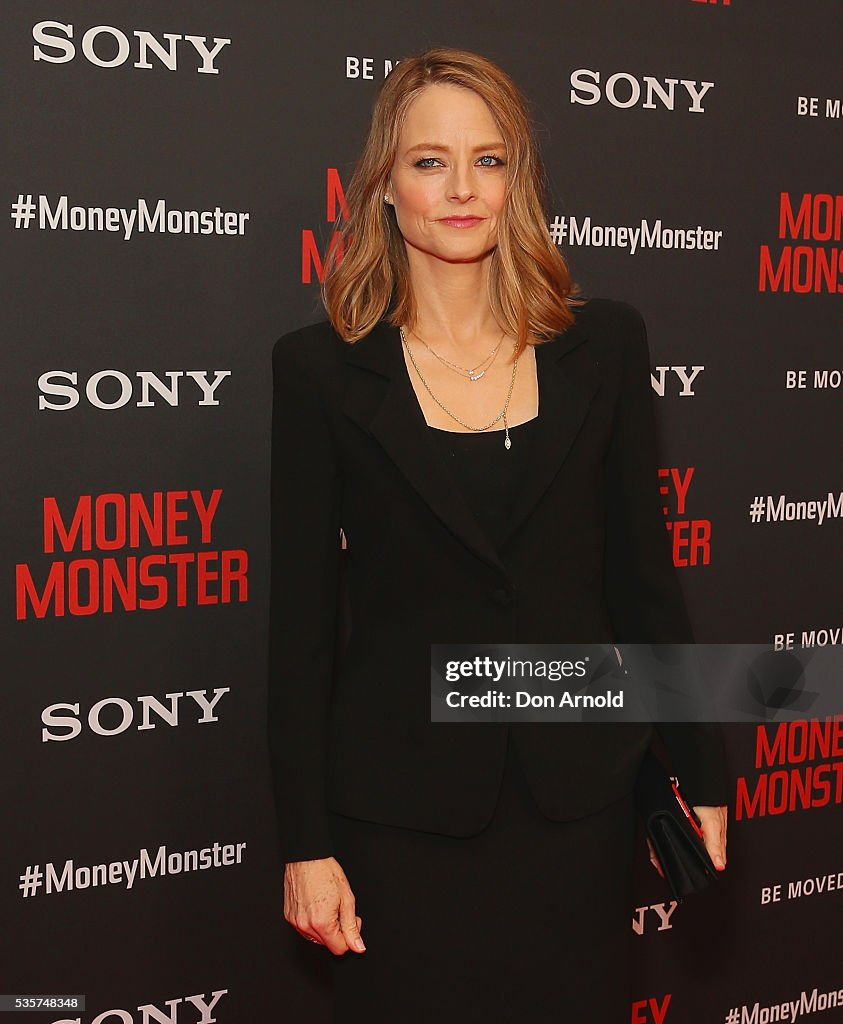Considering the fashion choices of the individual, what might be inferred about the formality of the event and the fashion trends at the time the photo was taken? The individual's attire, featuring a tailored black blazer over a black top, strongly indicates that she is attending a formal or semi-formal event. The simplicity and elegance of her outfit, complemented by understated jewelry, communicate a preference for classic and sophisticated fashion, which is often suitable for formal occasions. The black clutch she holds further aligns with her formal look and is commonly associated with such events. The fashion style, characterized by clean lines and minimal embellishments, aligns with contemporary trends favoring minimalism and timeless elegance. Given the promotional backdrop referencing a movie or media project, it is plausible that the event is professional in nature, possibly linked to the film or entertainment industry. 